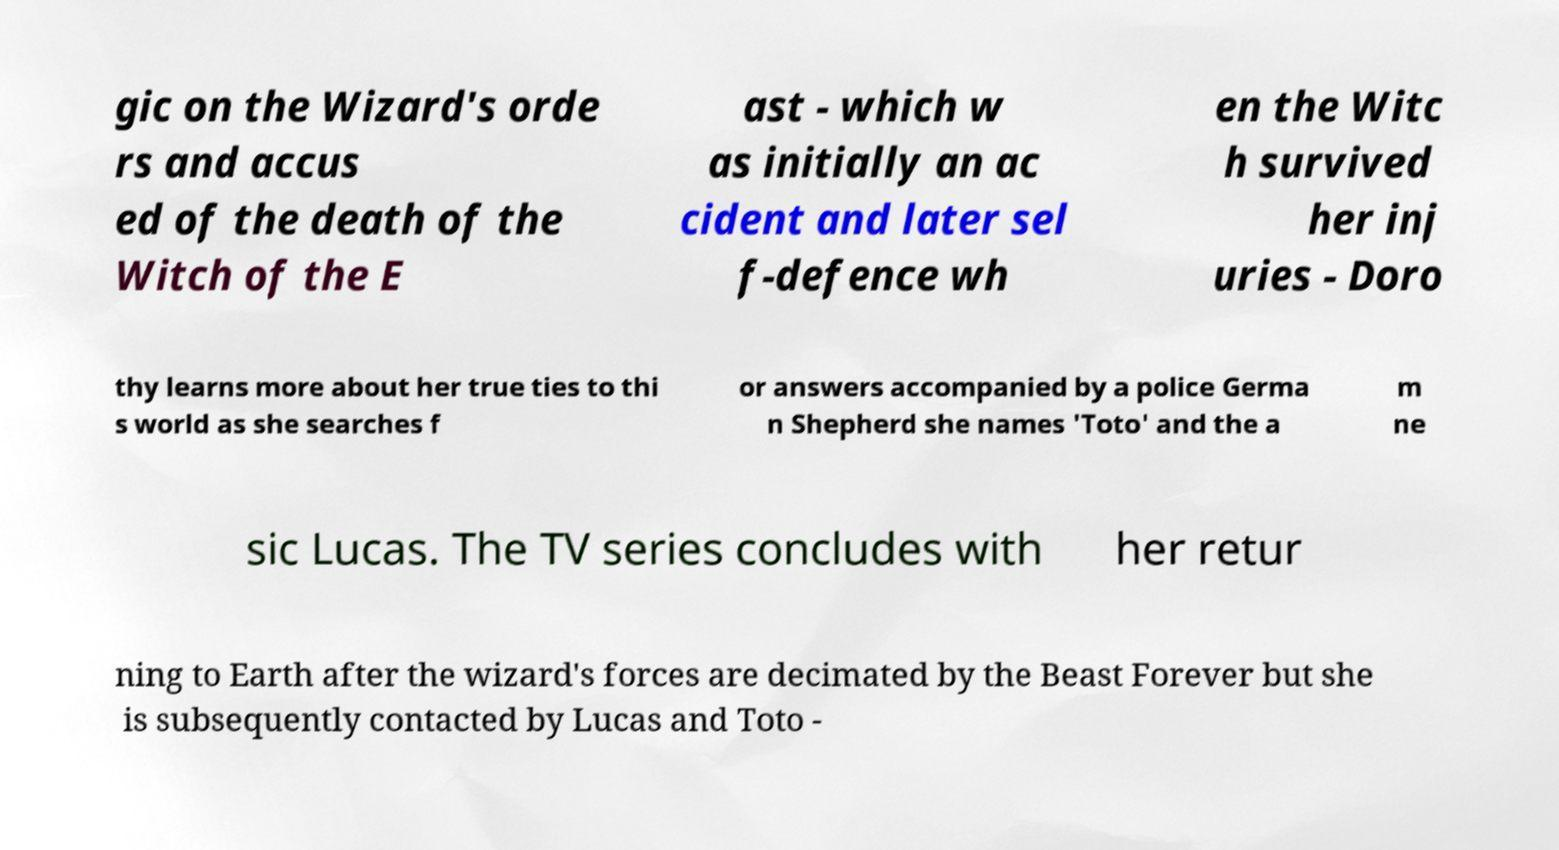There's text embedded in this image that I need extracted. Can you transcribe it verbatim? gic on the Wizard's orde rs and accus ed of the death of the Witch of the E ast - which w as initially an ac cident and later sel f-defence wh en the Witc h survived her inj uries - Doro thy learns more about her true ties to thi s world as she searches f or answers accompanied by a police Germa n Shepherd she names 'Toto' and the a m ne sic Lucas. The TV series concludes with her retur ning to Earth after the wizard's forces are decimated by the Beast Forever but she is subsequently contacted by Lucas and Toto - 